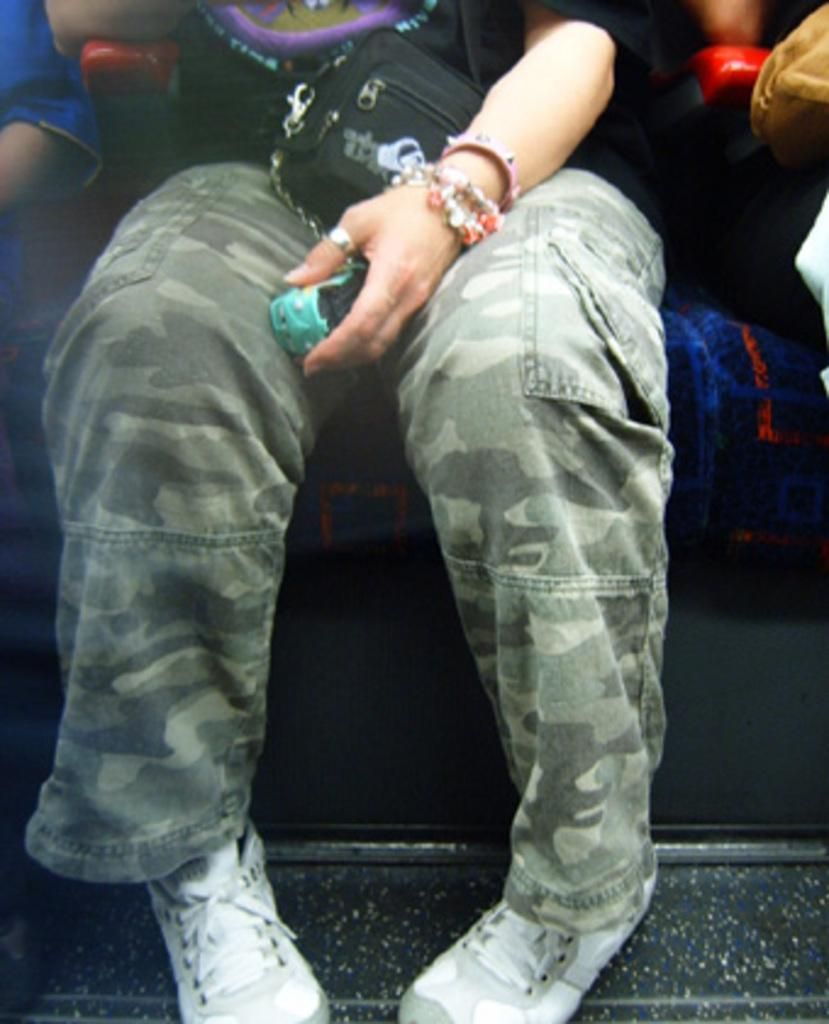Who is the main subject in the image? There is a lady in the image. What is the lady doing in the image? The lady is sitting on a sofa. Where is the lady located in the image? The lady is in the center of the image. What is the lady holding or carrying in the image? The lady has a small bag on her lap. What type of wrench is the lady using to fix the system in the image? There is no wrench or system present in the image; the lady is simply sitting on a sofa with a small bag on her lap. 